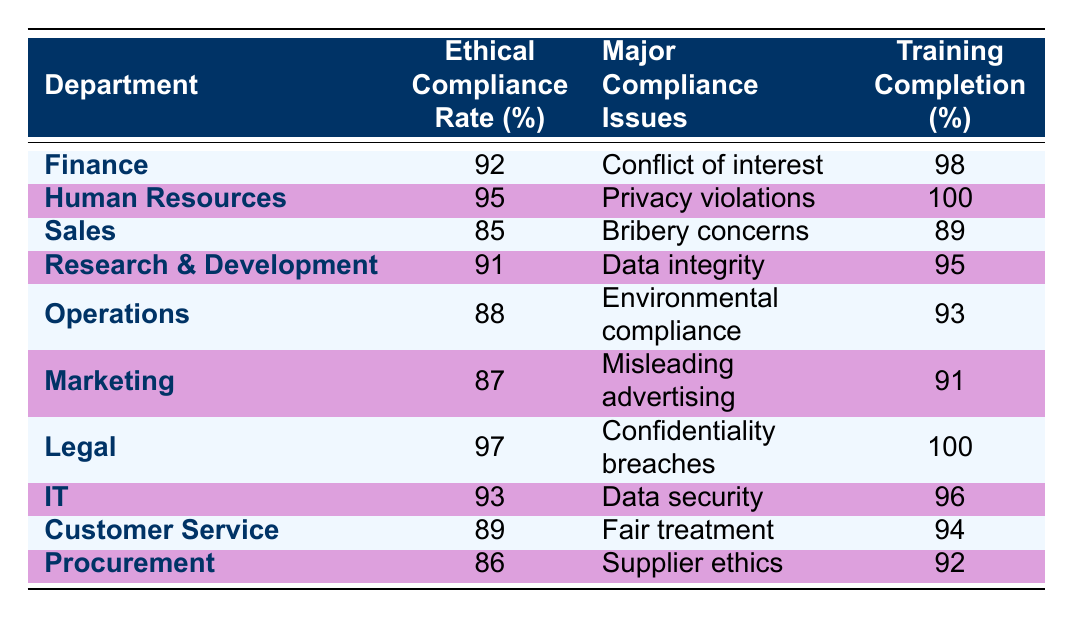What is the ethical compliance rate of the Human Resources department? The table lists the ethical compliance rate for each department. For Human Resources, the rate is shown directly as 95%.
Answer: 95% Which department has the highest ethical compliance rate? Looking at the table, the Legal department has the highest ethical compliance rate at 97%.
Answer: 97% What are the major compliance issues for the Sales department? The table specifies that the major compliance issue for the Sales department is "Bribery concerns."
Answer: Bribery concerns Calculate the average training completion rate across all departments. To find the average training completion rate, we sum all the completion rates: (98 + 100 + 89 + 95 + 93 + 91 + 100 + 96 + 94 + 92) =  10,703. Then, divide by the number of departments (10): 1073/10 = 97.3.
Answer: 97.3 Is the ethical compliance rate for Operations greater than that for Marketing? The ethical compliance rate for Operations is 88%, while for Marketing it is 87%. Since 88% is greater than 87%, the statement is true.
Answer: Yes How many departments have training completion rates below 90%? By examining the training completion rates in the table, the departments with rates below 90% are Sales (89%) and Customer Service (89%). Thus, there are two departments.
Answer: 2 Which departments have major compliance issues related to privacy? In the table, only the Human Resources department has a major compliance issue related to privacy, specifically "Privacy violations."
Answer: Human Resources What is the difference between the highest and lowest ethical compliance rates? The highest ethical compliance rate is 97% (Legal), and the lowest is 85% (Sales). Therefore, the difference is 97% - 85% = 12%.
Answer: 12% 